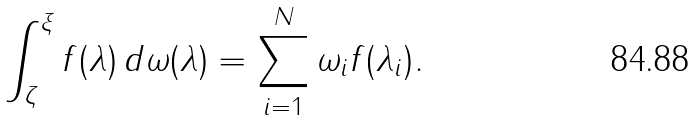<formula> <loc_0><loc_0><loc_500><loc_500>\int _ { \zeta } ^ { \xi } f ( \lambda ) \, d \omega ( \lambda ) = \sum _ { i = 1 } ^ { N } \omega _ { i } f ( \lambda _ { i } ) .</formula> 